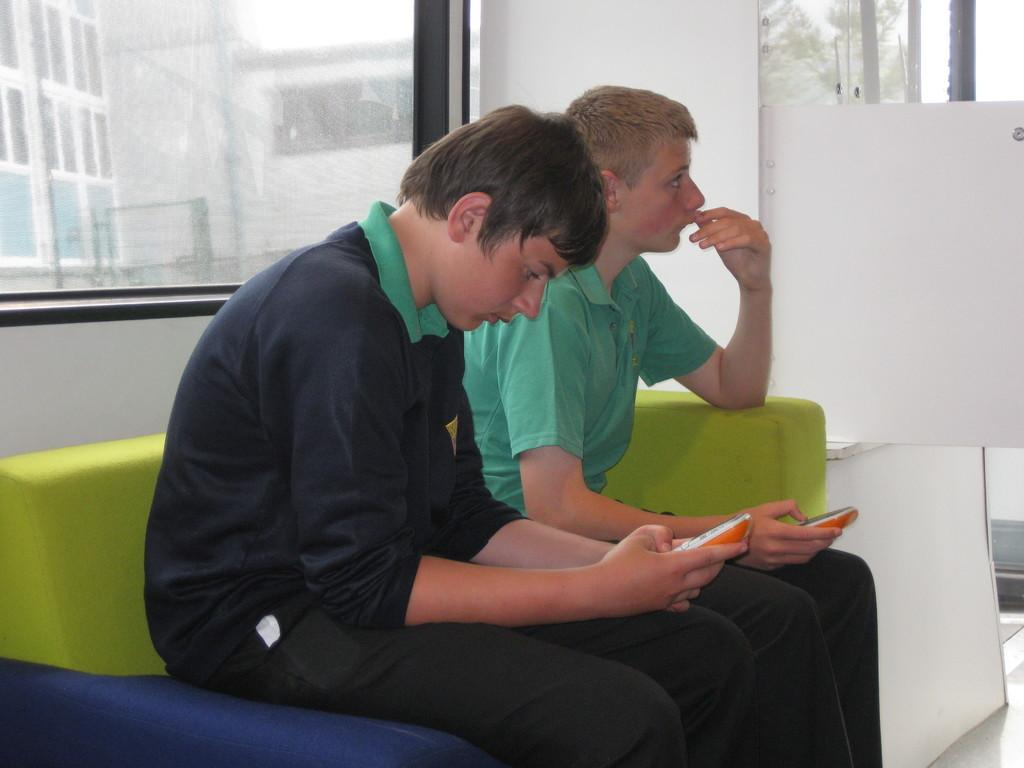How many people are sitting on the sofa in the image? There are two people sitting on the sofa in the image. Where is the sofa located in the image? The sofa is in the middle of the image. What is on the right side of the image? There is a white color board on the right side of the image. What can be seen in the background of the image? There is a glass window in the background of the image. How many trees can be seen through the glass window in the image? There is no tree visible through the glass window in the image. Is there a river flowing in the background of the image? There is no river present in the image. 